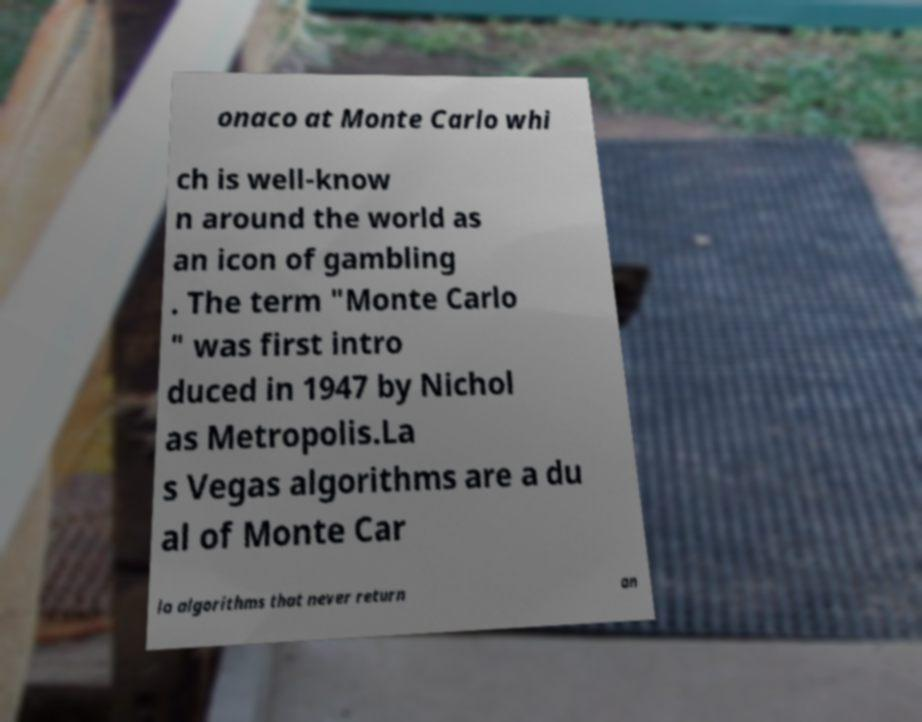Can you accurately transcribe the text from the provided image for me? onaco at Monte Carlo whi ch is well-know n around the world as an icon of gambling . The term "Monte Carlo " was first intro duced in 1947 by Nichol as Metropolis.La s Vegas algorithms are a du al of Monte Car lo algorithms that never return an 